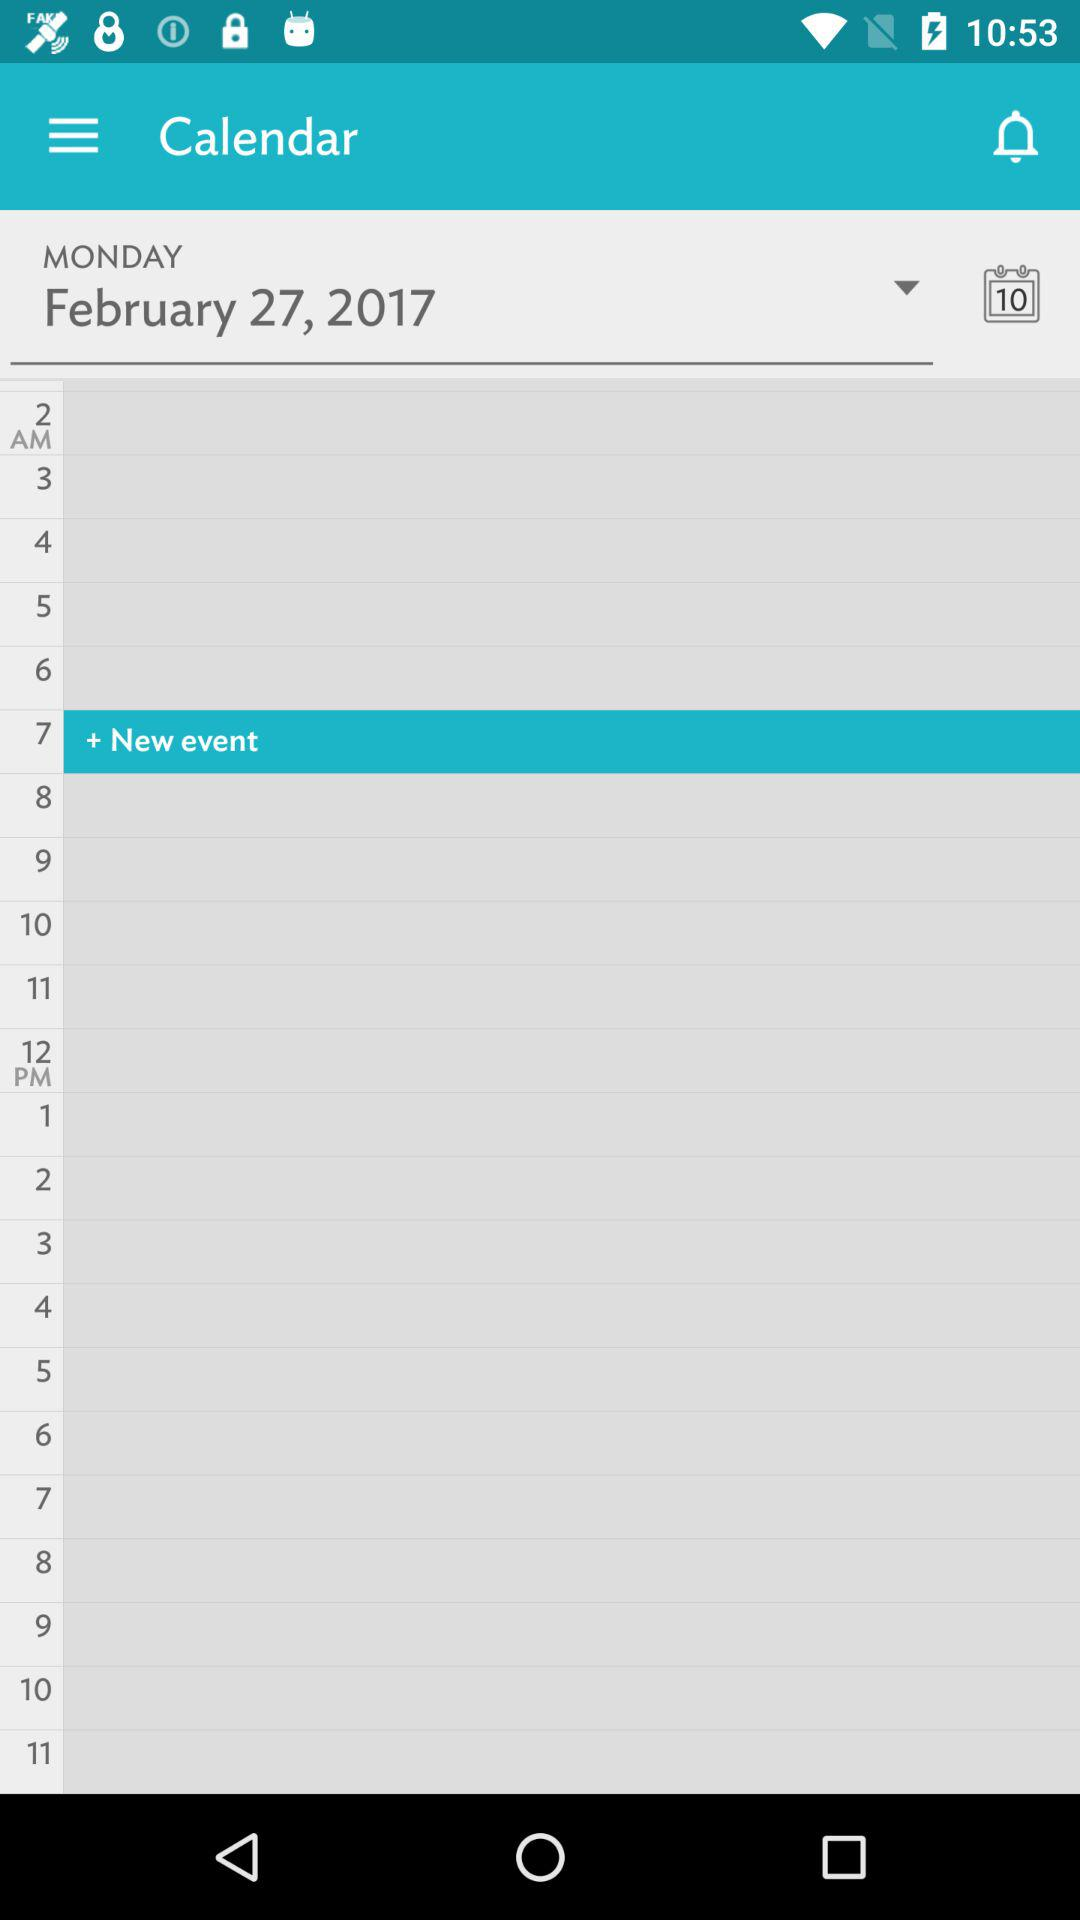What is the day on the given date? The given day is Monday. 